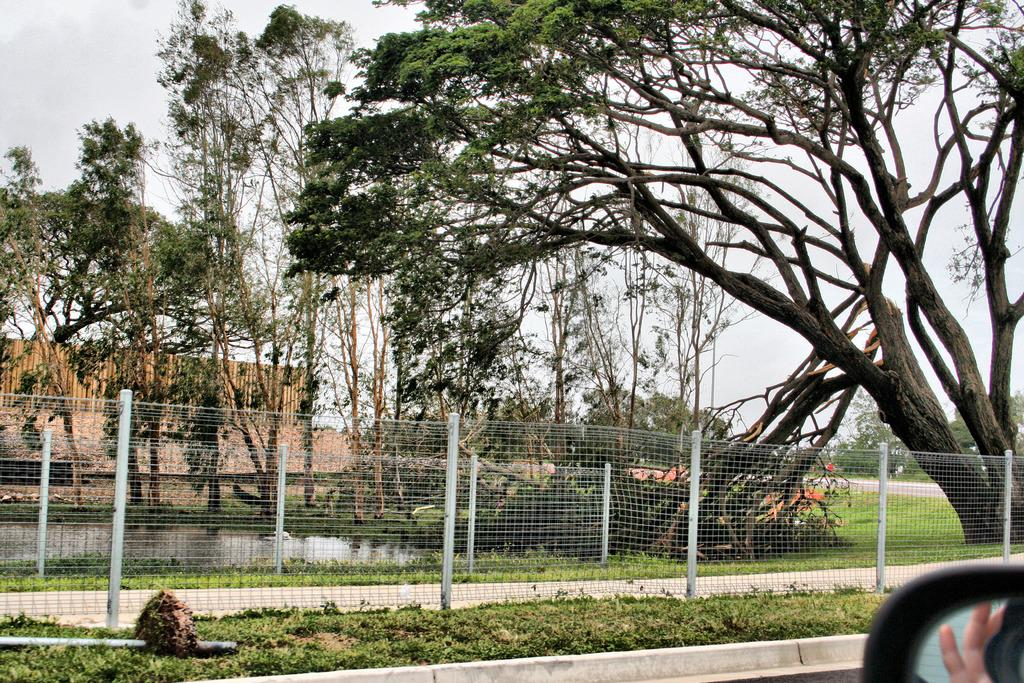What part of a car can be seen in the image? The side mirror of a car is visible in the image. What type of terrain is depicted in the image? There is grass on the ground in the image. What type of barrier is present in the image? Metal fencing is present in the image. What can be seen in the background of the image? There are trees, water, a wooden wall, and the sky visible in the background of the image. How many rabbits are hopping on the wooden wall in the image? There are no rabbits present in the image; it features a side mirror of a car, grass, metal fencing, and various elements in the background. What type of paper is being used to create the wooden wall in the image? There is no paper used to create the wooden wall in the image; it is made of wood. 